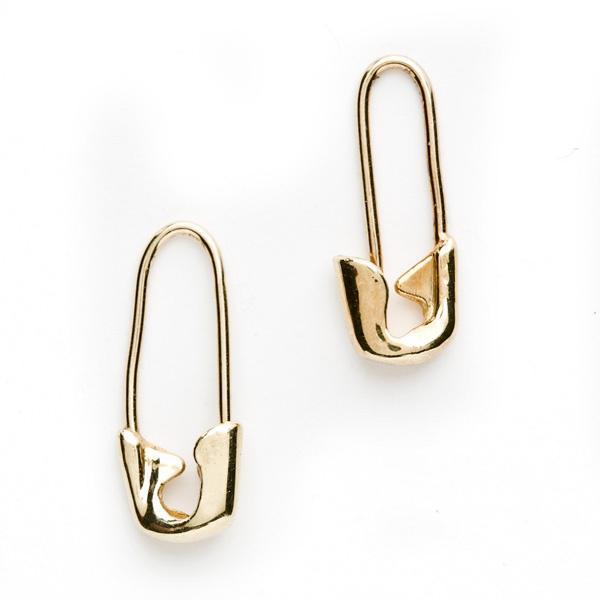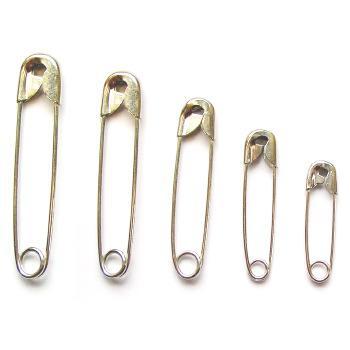The first image is the image on the left, the second image is the image on the right. Considering the images on both sides, is "An image shows exactly two safety pins, displayed with their clasp ends at the bottom and designed with no loop ends." valid? Answer yes or no. Yes. The first image is the image on the left, the second image is the image on the right. Analyze the images presented: Is the assertion "In one image, no less than three safety pins are arranged in order next to each other by size" valid? Answer yes or no. Yes. 